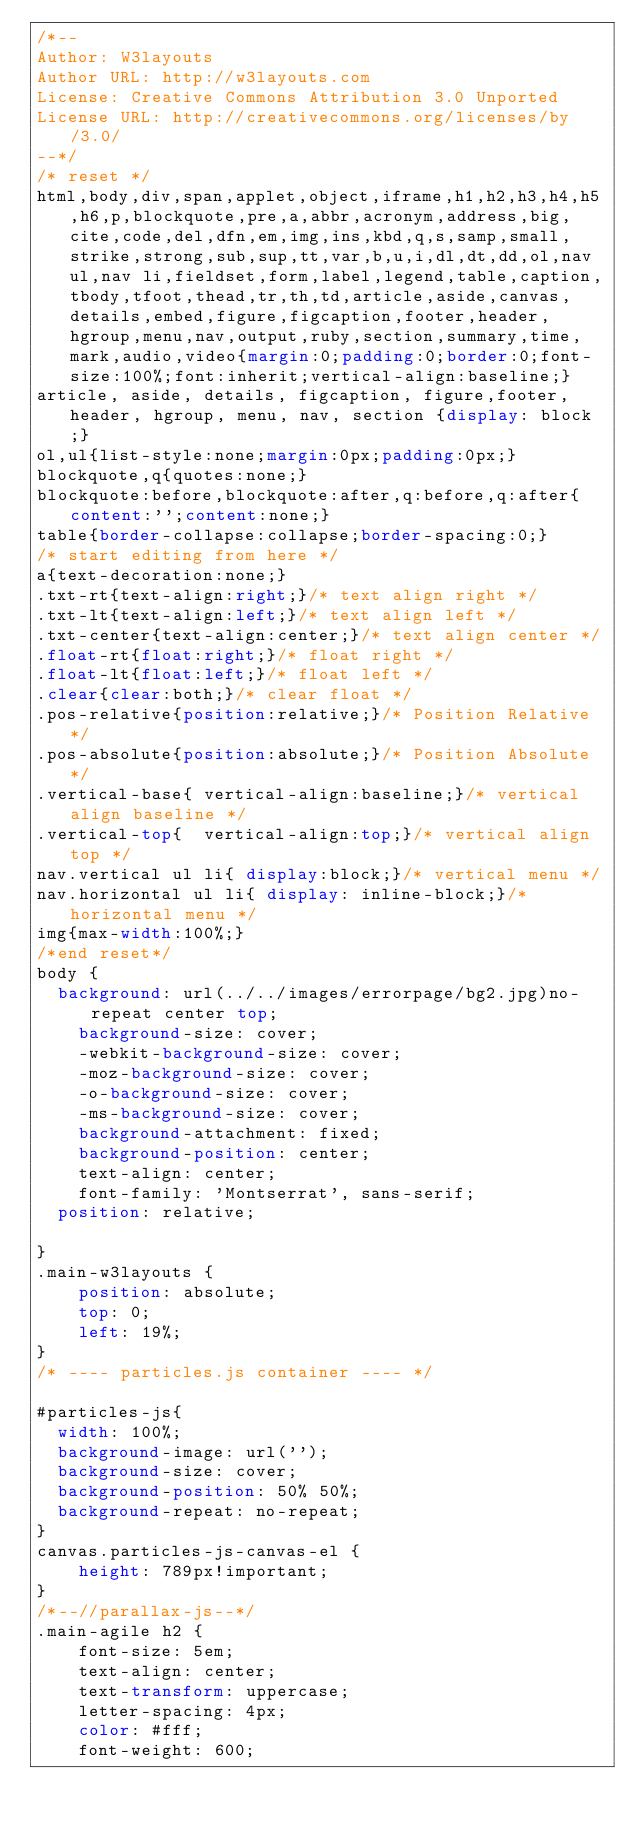<code> <loc_0><loc_0><loc_500><loc_500><_CSS_>/*--
Author: W3layouts
Author URL: http://w3layouts.com
License: Creative Commons Attribution 3.0 Unported
License URL: http://creativecommons.org/licenses/by/3.0/
--*/
/* reset */
html,body,div,span,applet,object,iframe,h1,h2,h3,h4,h5,h6,p,blockquote,pre,a,abbr,acronym,address,big,cite,code,del,dfn,em,img,ins,kbd,q,s,samp,small,strike,strong,sub,sup,tt,var,b,u,i,dl,dt,dd,ol,nav ul,nav li,fieldset,form,label,legend,table,caption,tbody,tfoot,thead,tr,th,td,article,aside,canvas,details,embed,figure,figcaption,footer,header,hgroup,menu,nav,output,ruby,section,summary,time,mark,audio,video{margin:0;padding:0;border:0;font-size:100%;font:inherit;vertical-align:baseline;}
article, aside, details, figcaption, figure,footer, header, hgroup, menu, nav, section {display: block;}
ol,ul{list-style:none;margin:0px;padding:0px;}
blockquote,q{quotes:none;}
blockquote:before,blockquote:after,q:before,q:after{content:'';content:none;}
table{border-collapse:collapse;border-spacing:0;}
/* start editing from here */
a{text-decoration:none;}
.txt-rt{text-align:right;}/* text align right */
.txt-lt{text-align:left;}/* text align left */
.txt-center{text-align:center;}/* text align center */
.float-rt{float:right;}/* float right */
.float-lt{float:left;}/* float left */
.clear{clear:both;}/* clear float */
.pos-relative{position:relative;}/* Position Relative */
.pos-absolute{position:absolute;}/* Position Absolute */
.vertical-base{	vertical-align:baseline;}/* vertical align baseline */
.vertical-top{	vertical-align:top;}/* vertical align top */
nav.vertical ul li{	display:block;}/* vertical menu */
nav.horizontal ul li{	display: inline-block;}/* horizontal menu */
img{max-width:100%;}
/*end reset*/
body {
	background: url(../../images/errorpage/bg2.jpg)no-repeat center top;
    background-size: cover;
    -webkit-background-size: cover;
    -moz-background-size: cover;
    -o-background-size: cover;
    -ms-background-size: cover;
    background-attachment: fixed;
    background-position: center;
    text-align: center;
    font-family: 'Montserrat', sans-serif;
	position: relative;
	
}
.main-w3layouts {
    position: absolute;
    top: 0;
    left: 19%;
}
/* ---- particles.js container ---- */

#particles-js{
  width: 100%;
  background-image: url('');
  background-size: cover;
  background-position: 50% 50%;
  background-repeat: no-repeat;
}
canvas.particles-js-canvas-el {
    height: 789px!important;
}
/*--//parallax-js--*/
.main-agile h2 {
    font-size: 5em;
    text-align: center;
    text-transform: uppercase;
    letter-spacing: 4px;
    color: #fff;
    font-weight: 600;</code> 